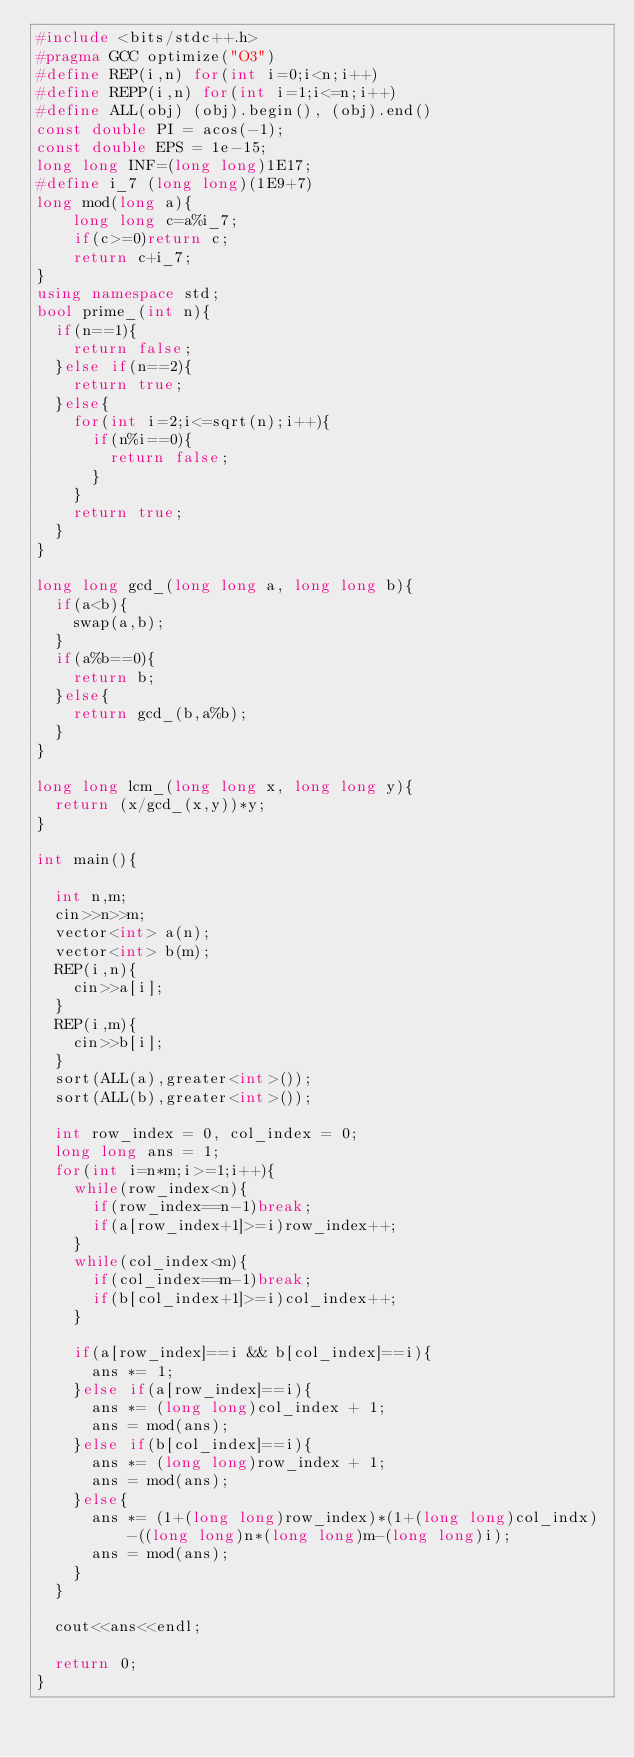Convert code to text. <code><loc_0><loc_0><loc_500><loc_500><_C++_>#include <bits/stdc++.h>
#pragma GCC optimize("O3")
#define REP(i,n) for(int i=0;i<n;i++)
#define REPP(i,n) for(int i=1;i<=n;i++)
#define ALL(obj) (obj).begin(), (obj).end()
const double PI = acos(-1);
const double EPS = 1e-15;
long long INF=(long long)1E17;
#define i_7 (long long)(1E9+7)
long mod(long a){
    long long c=a%i_7;
    if(c>=0)return c;
    return c+i_7;
}
using namespace std;
bool prime_(int n){
  if(n==1){
    return false;
  }else if(n==2){
    return true;
  }else{
    for(int i=2;i<=sqrt(n);i++){
      if(n%i==0){
        return false;
      }
    }
    return true;
  }
}

long long gcd_(long long a, long long b){
  if(a<b){
    swap(a,b);
  }
  if(a%b==0){
    return b;
  }else{
    return gcd_(b,a%b);
  }
}
 
long long lcm_(long long x, long long y){
  return (x/gcd_(x,y))*y;
}

int main(){
  
  int n,m;
  cin>>n>>m;
  vector<int> a(n);
  vector<int> b(m);
  REP(i,n){
    cin>>a[i];
  }
  REP(i,m){
    cin>>b[i];
  }
  sort(ALL(a),greater<int>());
  sort(ALL(b),greater<int>());
  
  int row_index = 0, col_index = 0;
  long long ans = 1;
  for(int i=n*m;i>=1;i++){
    while(row_index<n){
      if(row_index==n-1)break;
      if(a[row_index+1]>=i)row_index++;
    }
    while(col_index<m){
      if(col_index==m-1)break;
      if(b[col_index+1]>=i)col_index++;
    }
    
    if(a[row_index]==i && b[col_index]==i){
      ans *= 1;
    }else if(a[row_index]==i){
      ans *= (long long)col_index + 1;
      ans = mod(ans);
    }else if(b[col_index]==i){
      ans *= (long long)row_index + 1;
      ans = mod(ans);
    }else{
      ans *= (1+(long long)row_index)*(1+(long long)col_indx)-((long long)n*(long long)m-(long long)i);
      ans = mod(ans);
    }
  }
  
  cout<<ans<<endl;
      
  return 0;
}
</code> 